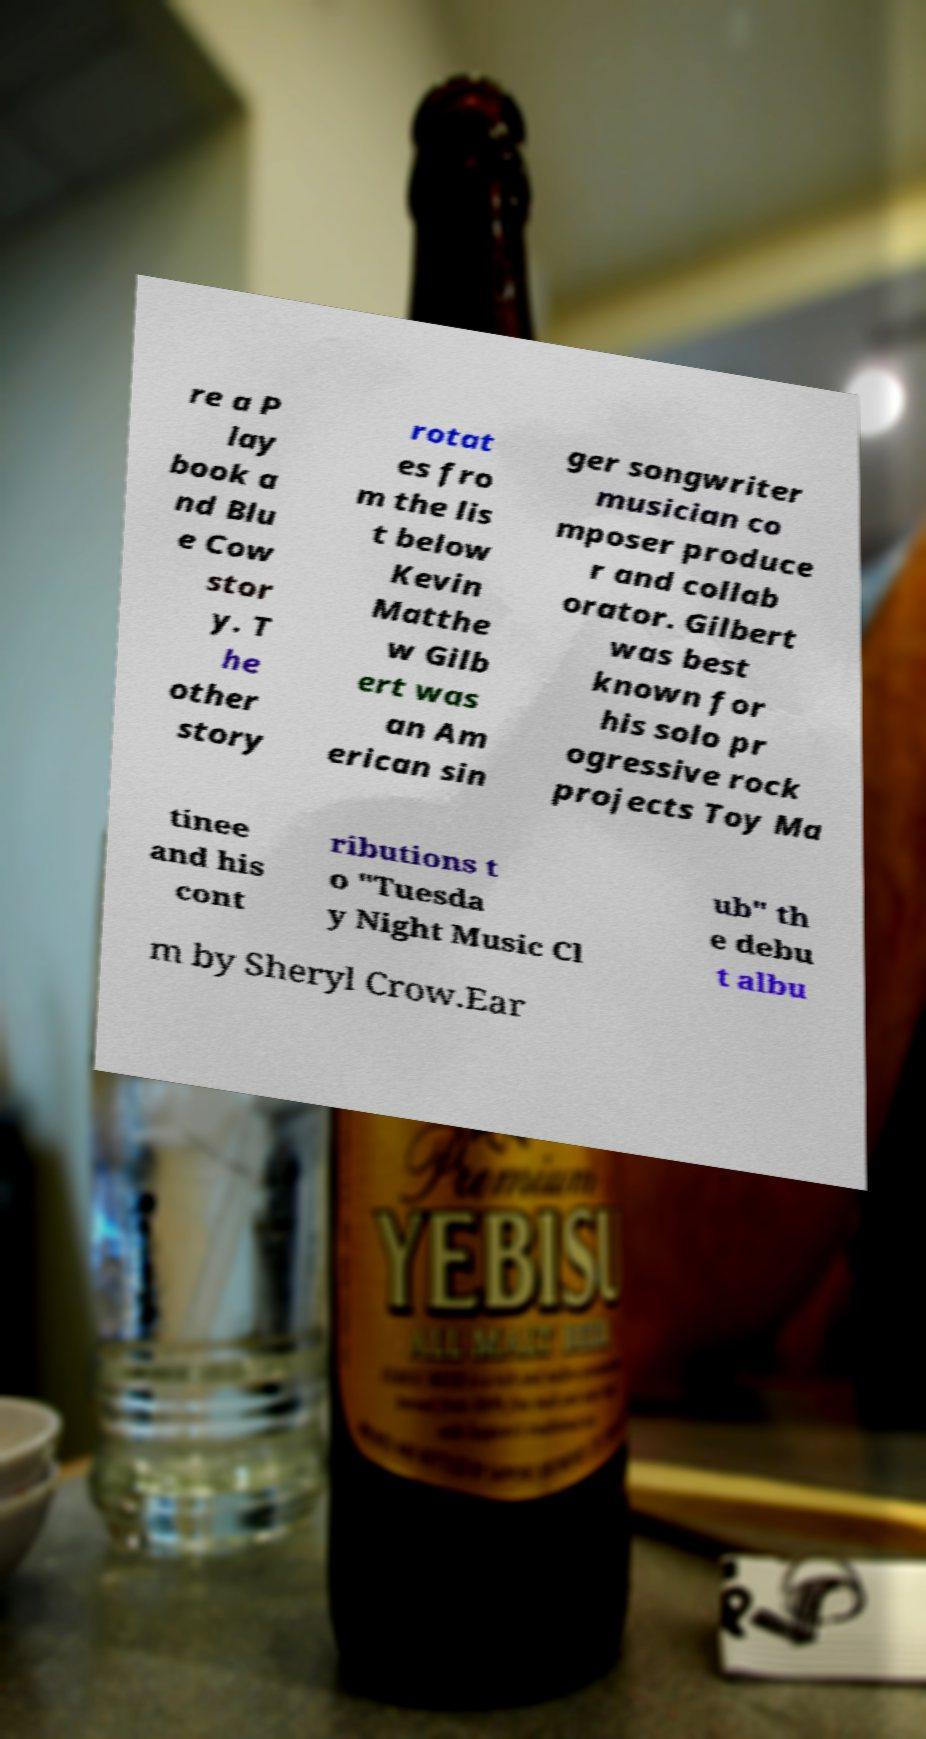I need the written content from this picture converted into text. Can you do that? re a P lay book a nd Blu e Cow stor y. T he other story rotat es fro m the lis t below Kevin Matthe w Gilb ert was an Am erican sin ger songwriter musician co mposer produce r and collab orator. Gilbert was best known for his solo pr ogressive rock projects Toy Ma tinee and his cont ributions t o "Tuesda y Night Music Cl ub" th e debu t albu m by Sheryl Crow.Ear 